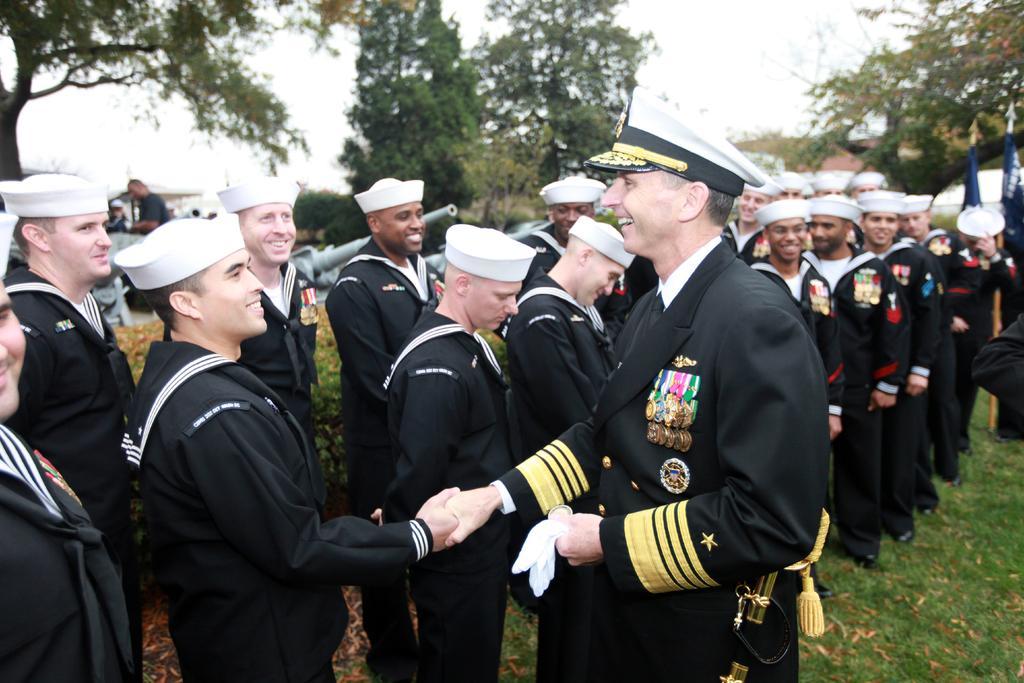In one or two sentences, can you explain what this image depicts? In this image there is grass. There are people standing. There are trees in the background. There is sky. 